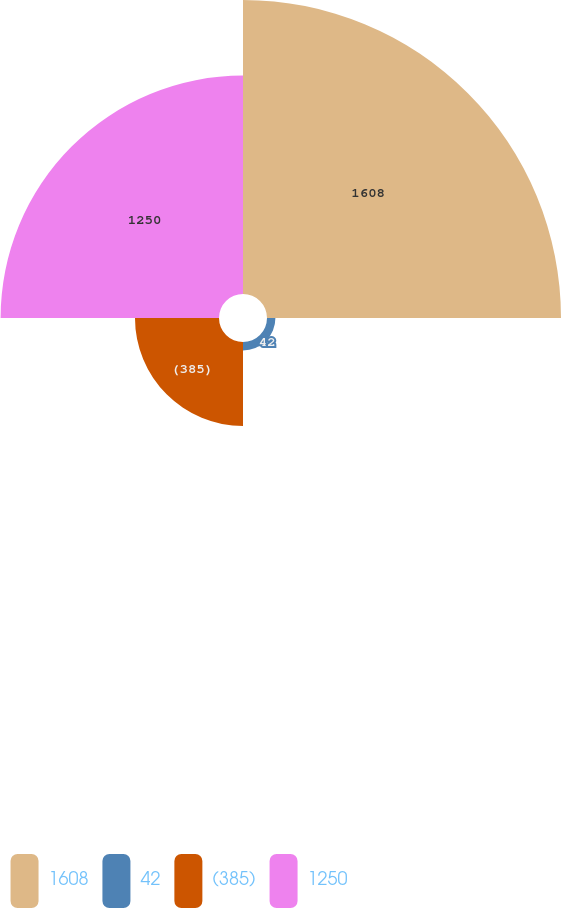<chart> <loc_0><loc_0><loc_500><loc_500><pie_chart><fcel>1608<fcel>42<fcel>(385)<fcel>1250<nl><fcel>48.61%<fcel>1.39%<fcel>13.89%<fcel>36.11%<nl></chart> 